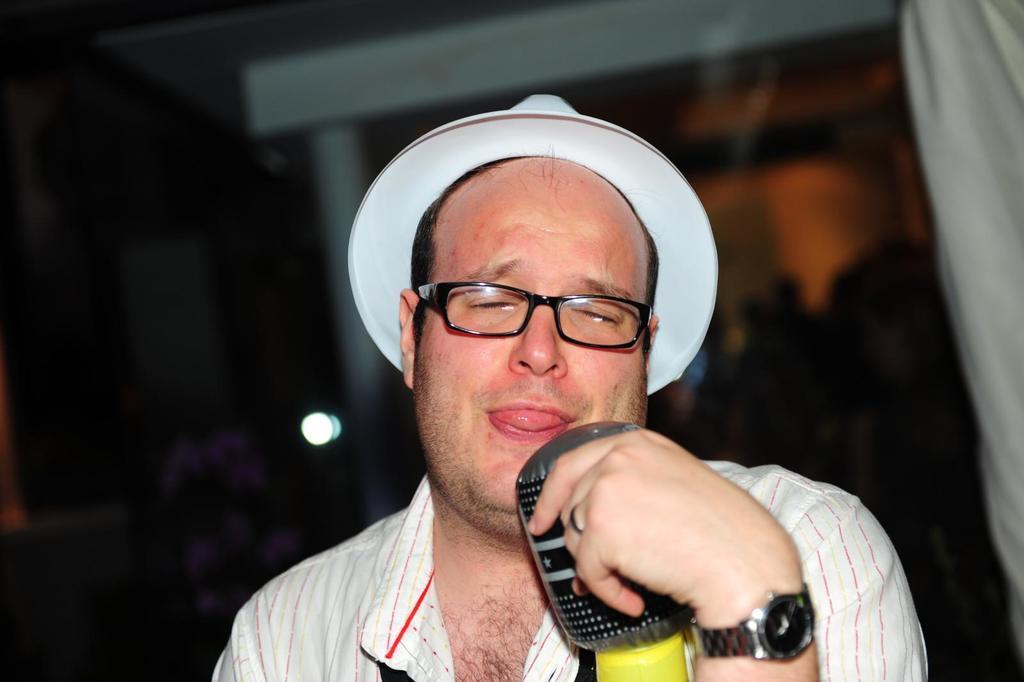Could you give a brief overview of what you see in this image? In this picture we can see a man is holding a object in his hand. 